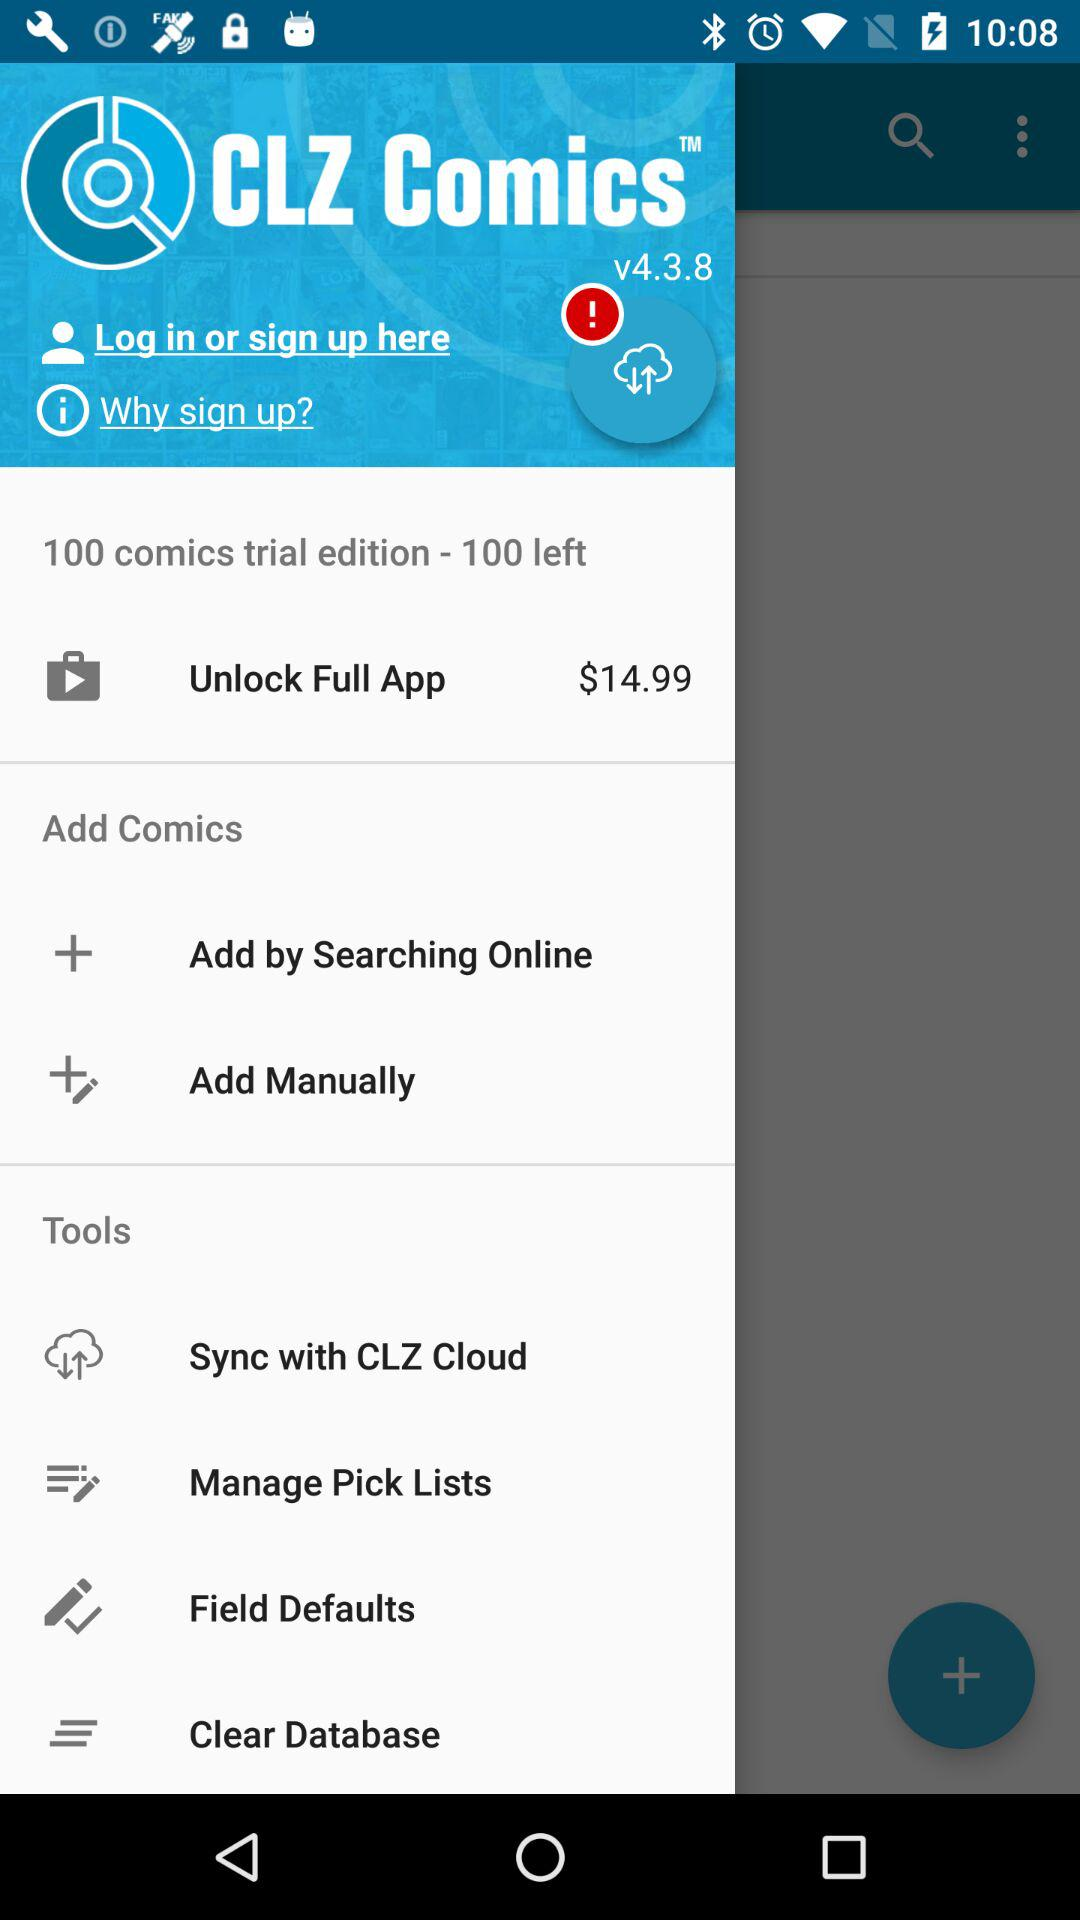How many more comics do I have left to unlock?
Answer the question using a single word or phrase. 100 